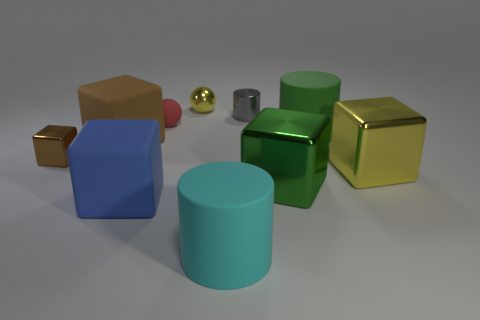What number of green objects are either rubber cylinders or tiny blocks?
Your answer should be very brief. 1. What is the color of the shiny ball?
Offer a very short reply. Yellow. There is a cyan thing that is made of the same material as the big green cylinder; what size is it?
Give a very brief answer. Large. What number of big yellow things are the same shape as the gray object?
Provide a short and direct response. 0. There is a yellow shiny thing that is behind the brown metallic thing to the left of the brown rubber object; how big is it?
Offer a terse response. Small. There is a brown thing that is the same size as the shiny cylinder; what material is it?
Make the answer very short. Metal. Are there any other tiny things that have the same material as the small yellow object?
Ensure brevity in your answer.  Yes. What color is the tiny sphere left of the yellow metal object left of the big matte cylinder in front of the brown rubber cube?
Make the answer very short. Red. Is the color of the big matte block behind the large blue cube the same as the metallic block that is on the left side of the cyan matte cylinder?
Provide a succinct answer. Yes. Is there anything else of the same color as the tiny metallic sphere?
Your response must be concise. Yes. 